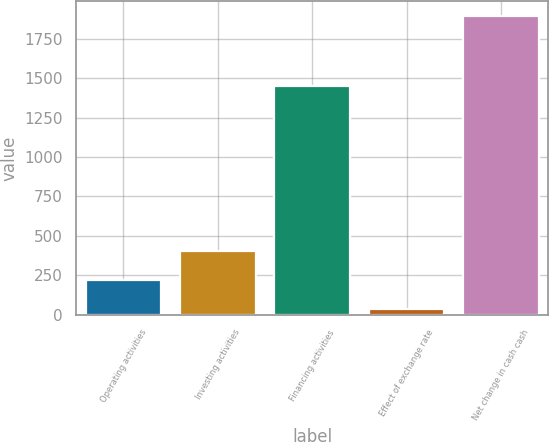Convert chart. <chart><loc_0><loc_0><loc_500><loc_500><bar_chart><fcel>Operating activities<fcel>Investing activities<fcel>Financing activities<fcel>Effect of exchange rate<fcel>Net change in cash cash<nl><fcel>220.5<fcel>406.4<fcel>1448.2<fcel>34.6<fcel>1893.6<nl></chart> 